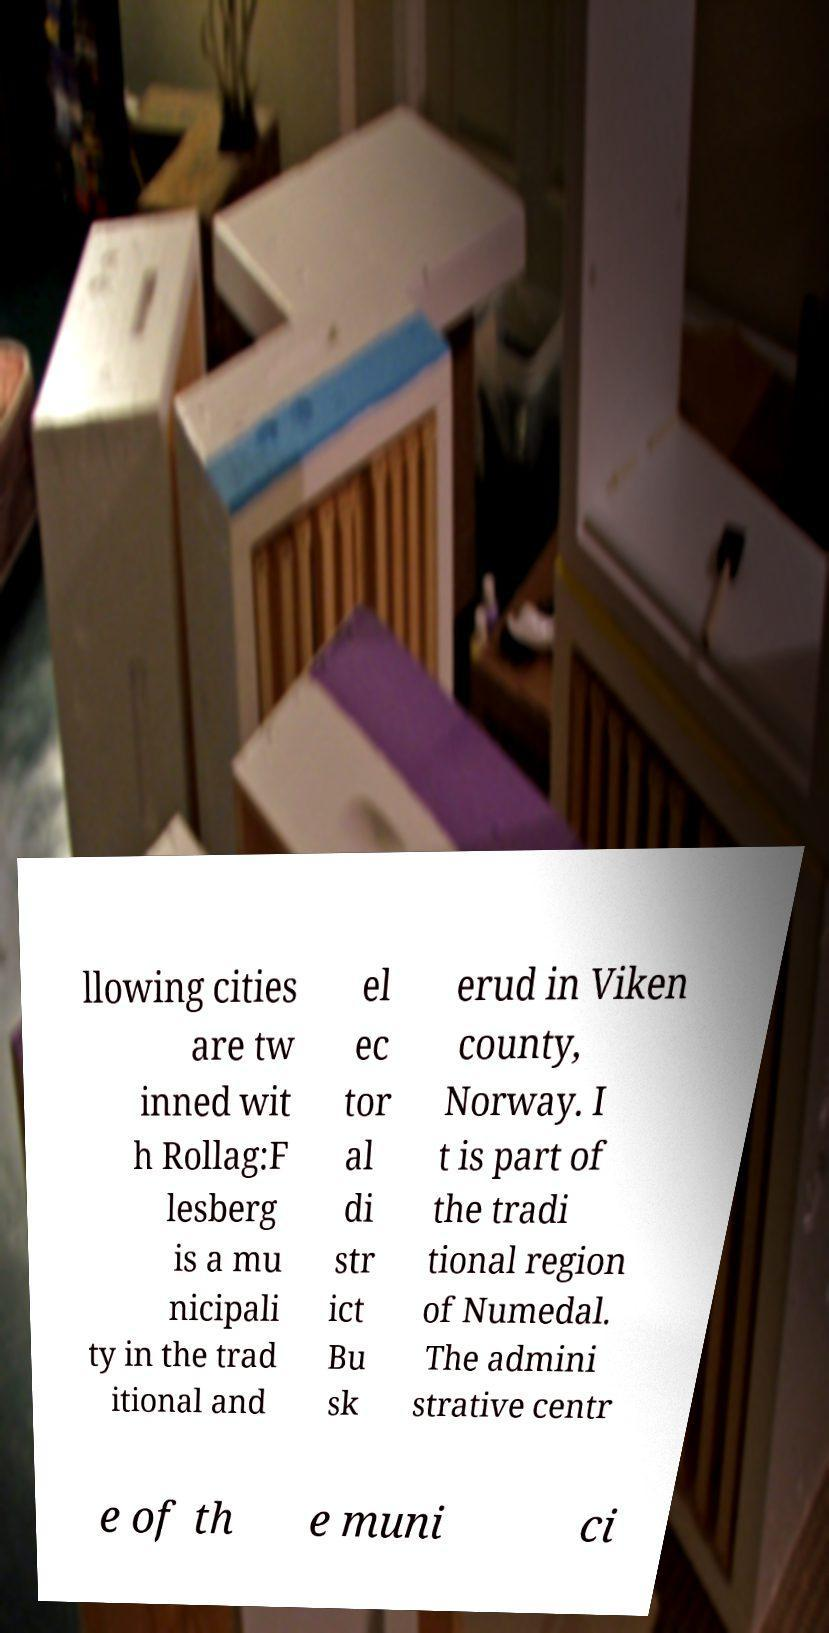What messages or text are displayed in this image? I need them in a readable, typed format. llowing cities are tw inned wit h Rollag:F lesberg is a mu nicipali ty in the trad itional and el ec tor al di str ict Bu sk erud in Viken county, Norway. I t is part of the tradi tional region of Numedal. The admini strative centr e of th e muni ci 